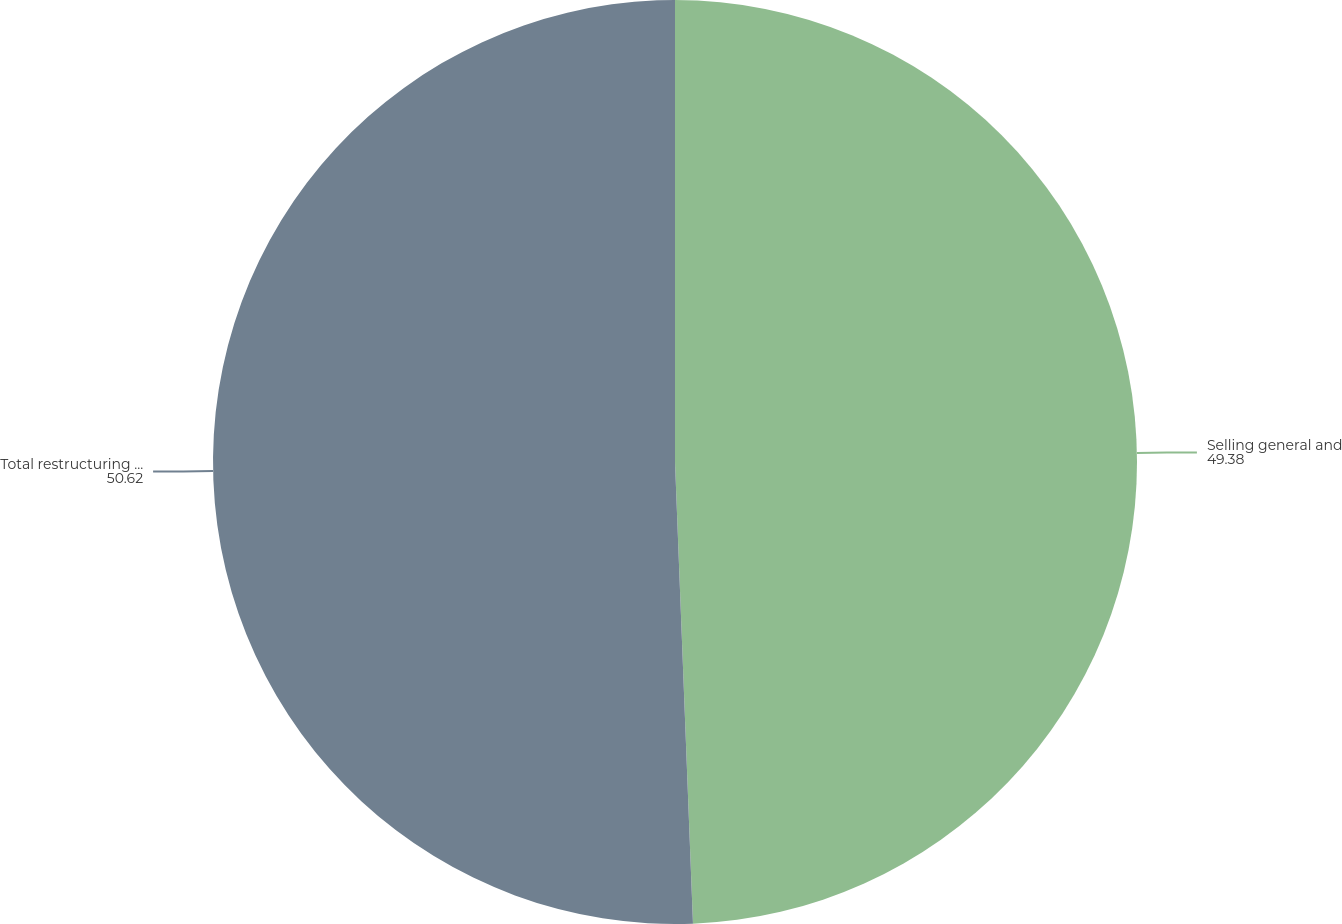<chart> <loc_0><loc_0><loc_500><loc_500><pie_chart><fcel>Selling general and<fcel>Total restructuring asset<nl><fcel>49.38%<fcel>50.62%<nl></chart> 